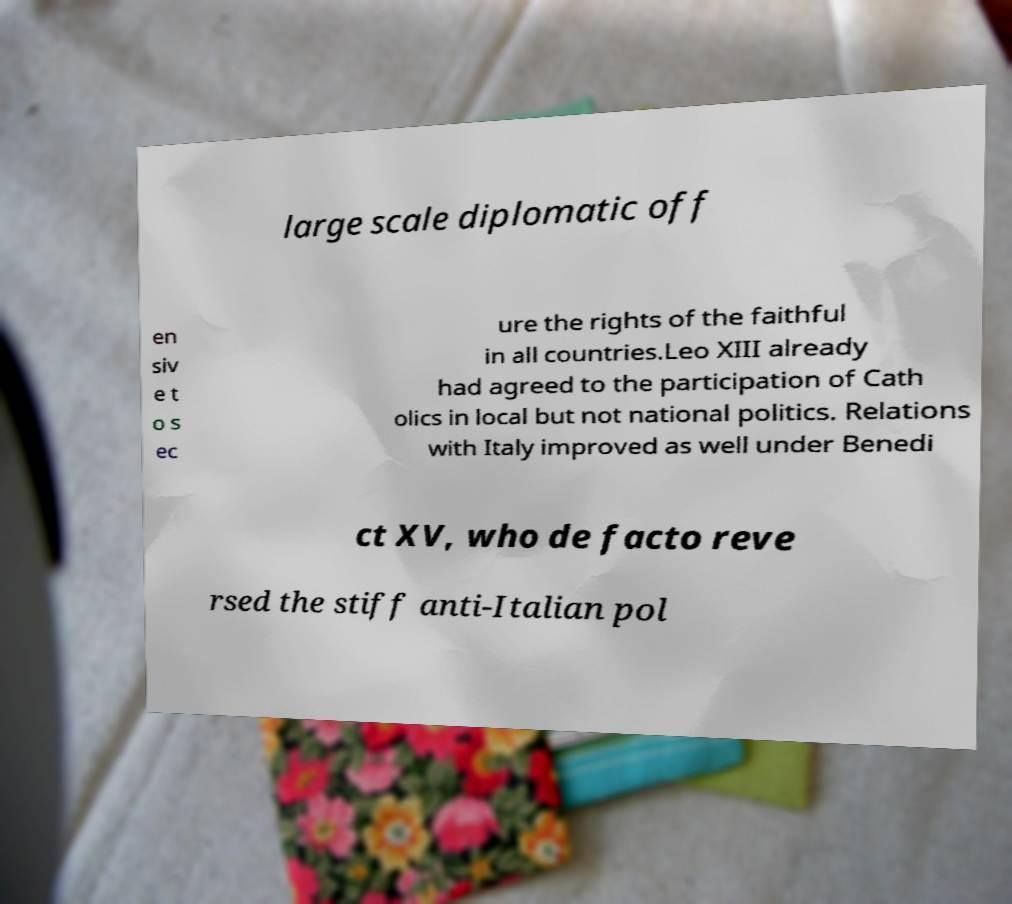Can you read and provide the text displayed in the image?This photo seems to have some interesting text. Can you extract and type it out for me? large scale diplomatic off en siv e t o s ec ure the rights of the faithful in all countries.Leo XIII already had agreed to the participation of Cath olics in local but not national politics. Relations with Italy improved as well under Benedi ct XV, who de facto reve rsed the stiff anti-Italian pol 